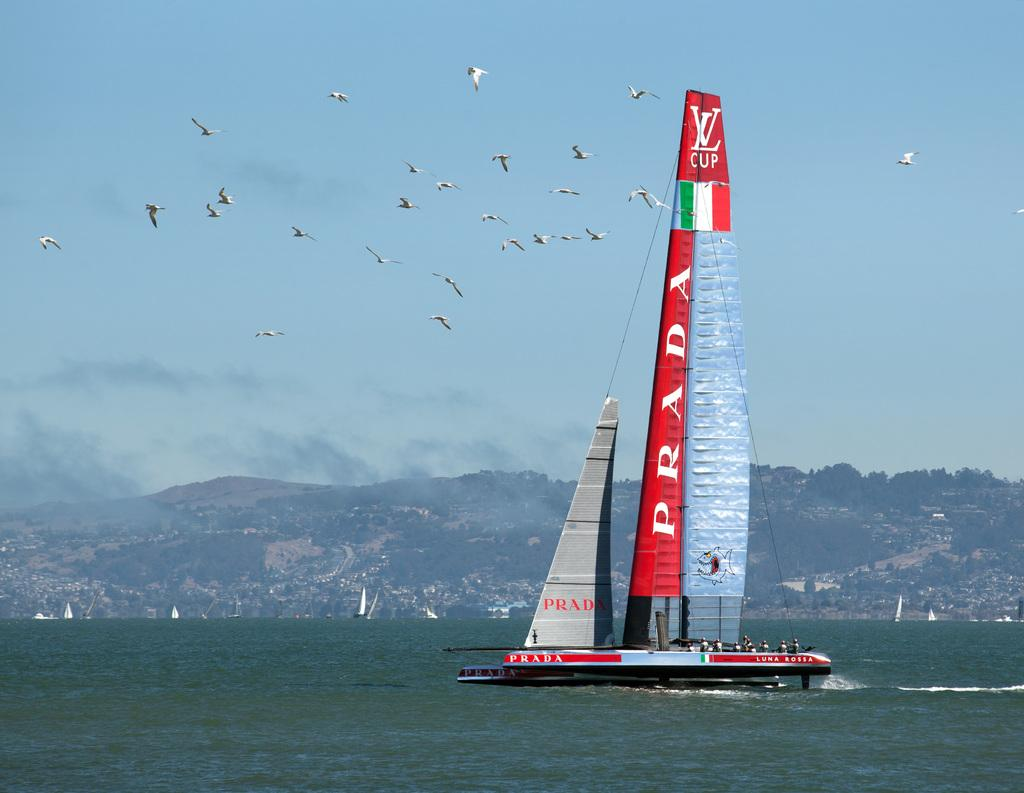What is on the water in the image? There are ships on the water in the image. What is happening in the air in the image? Birds are flying in the air in the image. What type of landscape feature can be seen in the image? There are hills visible in the image. What type of man-made structures are present in the image? There are buildings in the image. What type of vegetation is present in the image? Trees are present in the image. What is visible in the sky in the image? The sky is visible in the image, and clouds are present in the sky. What type of pail is being used to sense the rail in the image? There is no pail or rail present in the image; it features ships on the water, birds flying, hills, buildings, trees, and a sky with clouds. 